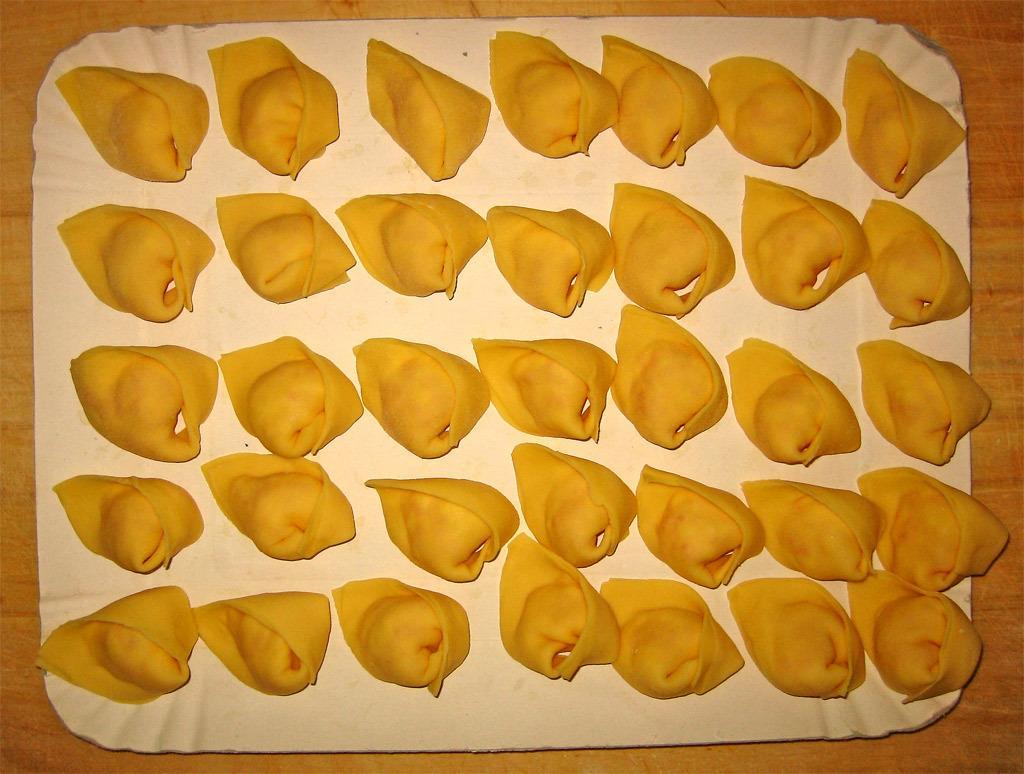How would you summarize this image in a sentence or two? In the center we can see a white color platter containing some food items and the platter is placed on the top of the wooden table. 